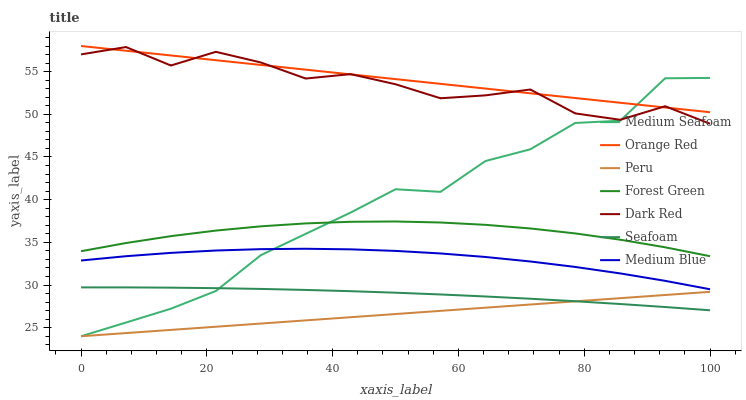Does Peru have the minimum area under the curve?
Answer yes or no. Yes. Does Orange Red have the maximum area under the curve?
Answer yes or no. Yes. Does Medium Blue have the minimum area under the curve?
Answer yes or no. No. Does Medium Blue have the maximum area under the curve?
Answer yes or no. No. Is Orange Red the smoothest?
Answer yes or no. Yes. Is Dark Red the roughest?
Answer yes or no. Yes. Is Medium Blue the smoothest?
Answer yes or no. No. Is Medium Blue the roughest?
Answer yes or no. No. Does Peru have the lowest value?
Answer yes or no. Yes. Does Medium Blue have the lowest value?
Answer yes or no. No. Does Orange Red have the highest value?
Answer yes or no. Yes. Does Medium Blue have the highest value?
Answer yes or no. No. Is Medium Blue less than Forest Green?
Answer yes or no. Yes. Is Forest Green greater than Seafoam?
Answer yes or no. Yes. Does Dark Red intersect Orange Red?
Answer yes or no. Yes. Is Dark Red less than Orange Red?
Answer yes or no. No. Is Dark Red greater than Orange Red?
Answer yes or no. No. Does Medium Blue intersect Forest Green?
Answer yes or no. No. 